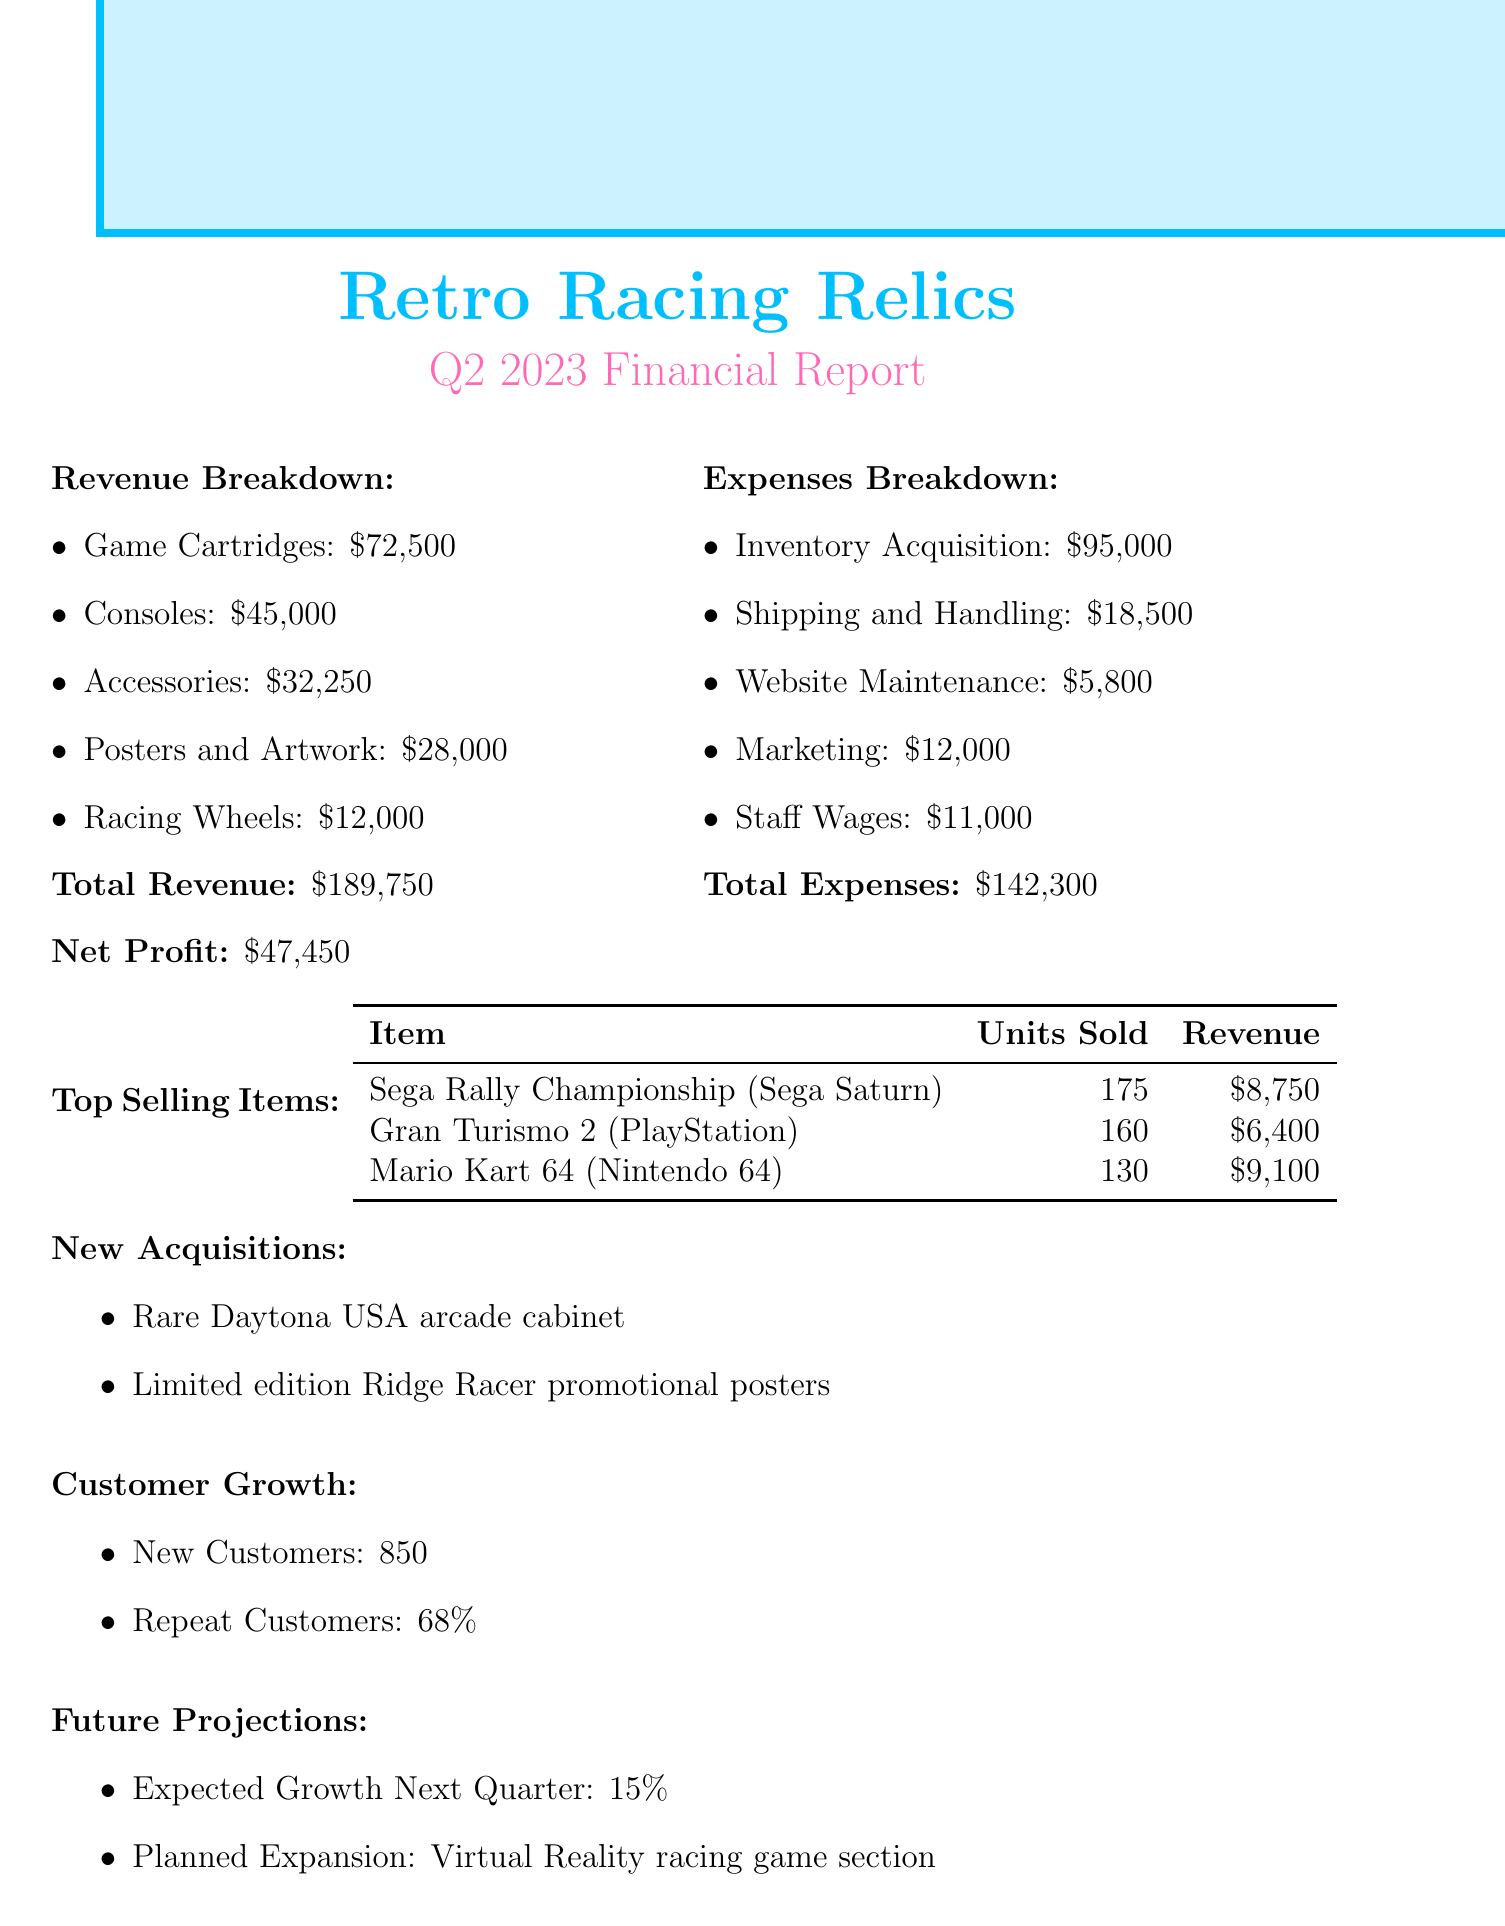What is the total revenue? The total revenue is listed at the end of the revenue breakdown section in the document, which sums up all revenue sources.
Answer: $189,750 What is the net profit for Q2 2023? The net profit is specifically stated in the document after the revenue and expenses sections.
Answer: $47,450 How many units were sold of "Sega Rally Championship"? The number of units sold for each top-selling item is detailed in the table provided.
Answer: 175 What percentage of customers are repeat customers? The repeat customers percentage is mentioned under the customer growth section.
Answer: 68% What item generated the highest revenue in sales? By comparing the revenue for each top-selling item, "Sega Rally Championship" has the highest revenue.
Answer: Sega Rally Championship (Sega Saturn) What were the total expenses? The total expenses figure is mentioned at the end of the expenses breakdown section in the document.
Answer: $142,300 What is the expected growth for the next quarter? The expected growth percentage is provided in the future projections section of the report.
Answer: 15% Which new acquisitions are noted in the report? The document lists the new acquisitions in a bullet-point format towards the end.
Answer: Rare Daytona USA arcade cabinet, Limited edition Ridge Racer promotional posters What is the total revenue from racing wheels? The breakdown for revenue sources includes racing wheels, specifically stated in the revenue breakdown section.
Answer: $12,000 